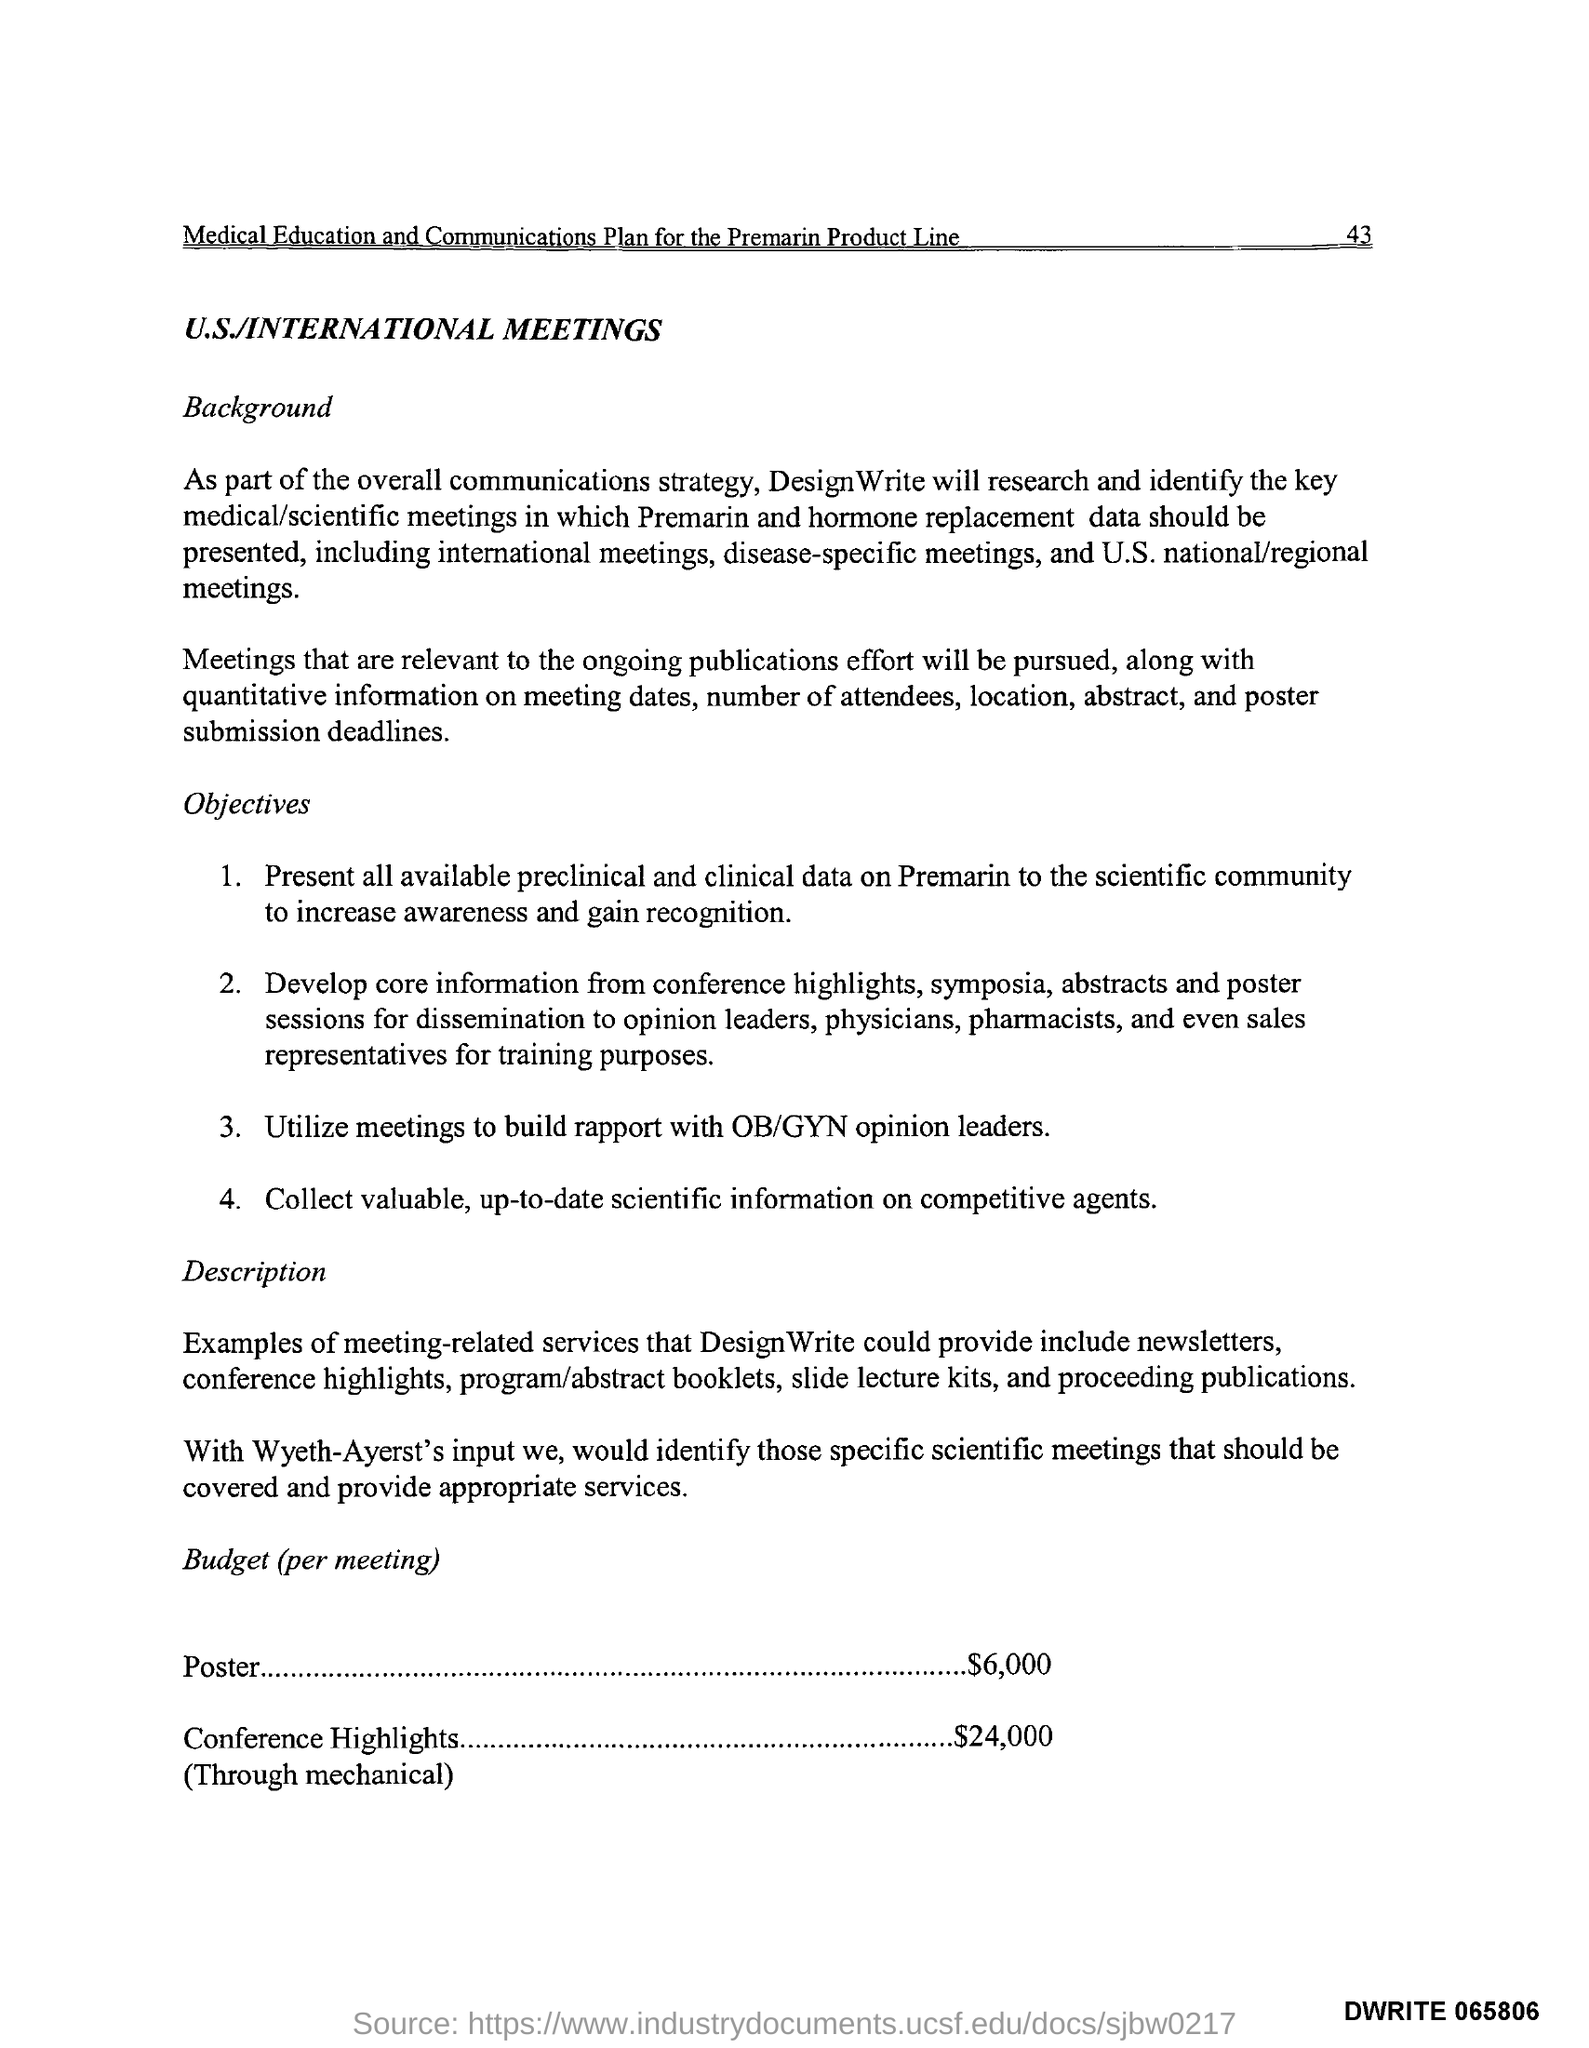How many dollars were used for Posters?
Offer a terse response. $6,000. What is the 4th objective of the meeting
Offer a terse response. Collect valuable, up-to-date scientific information on competitive agents. 